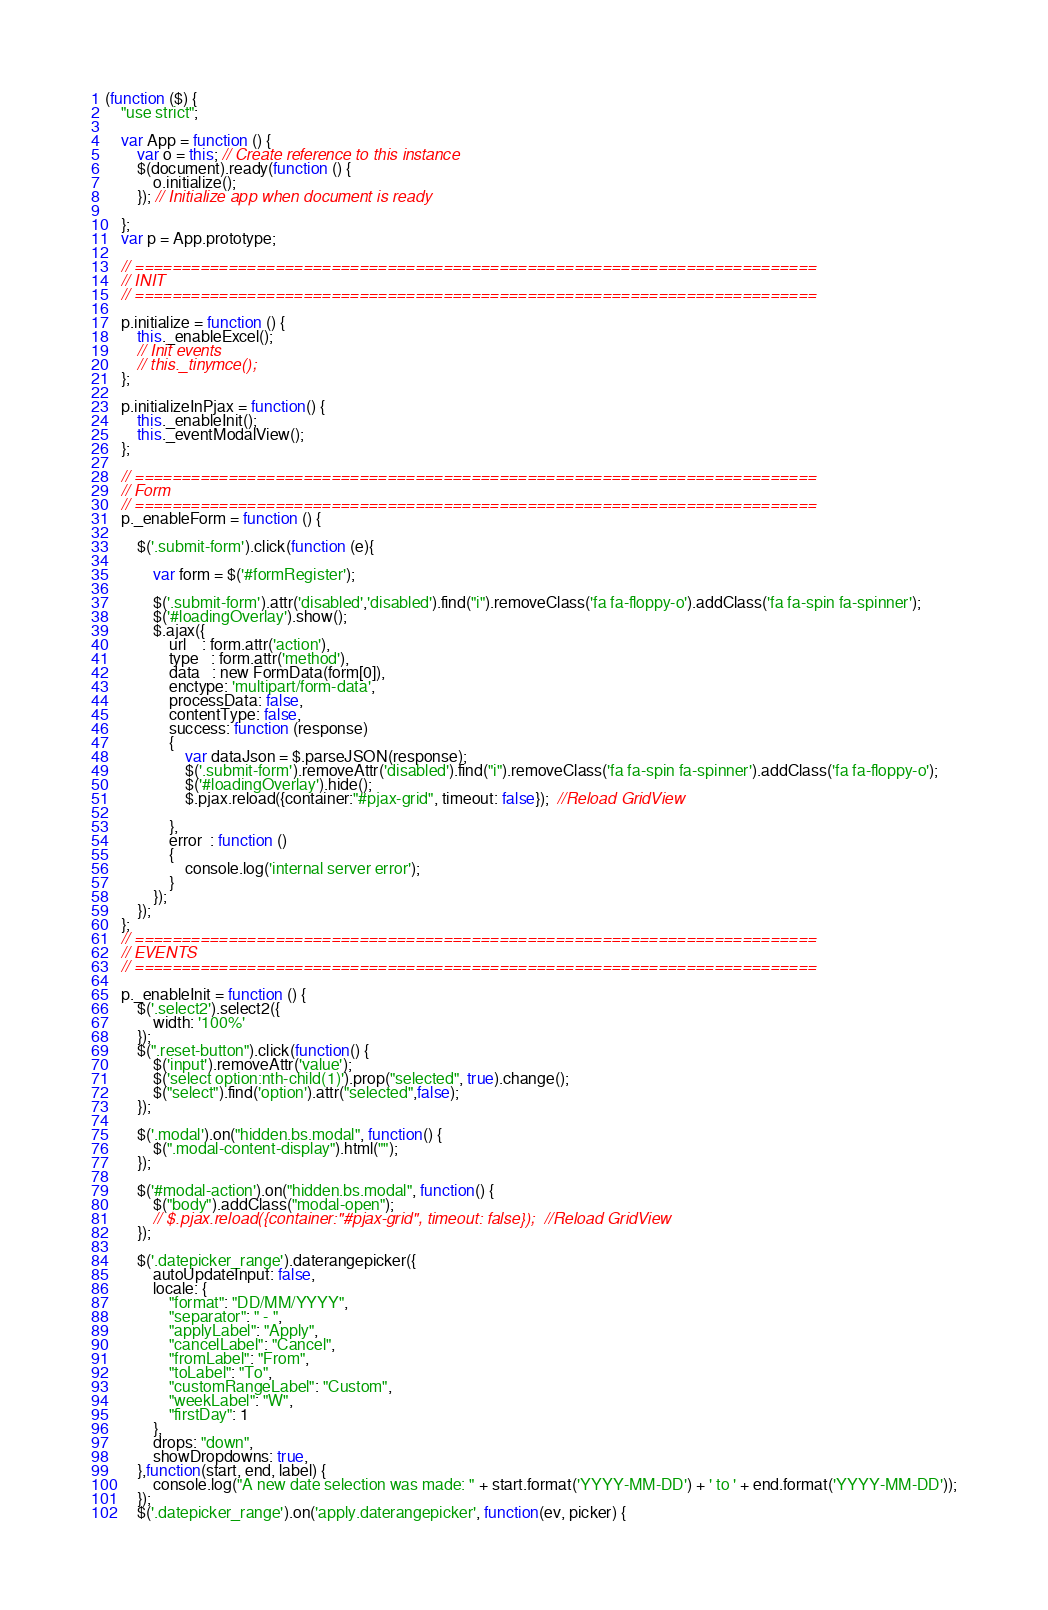Convert code to text. <code><loc_0><loc_0><loc_500><loc_500><_JavaScript_>(function ($) {
	"use strict";

	var App = function () {
		var o = this; // Create reference to this instance
		$(document).ready(function () {
			o.initialize();
		}); // Initialize app when document is ready

	};
	var p = App.prototype;

	// =========================================================================
	// INIT
	// =========================================================================

	p.initialize = function () {
		this._enableExcel();
		// Init events
        // this._tinymce();
    };

    p.initializeInPjax = function() {
    	this._enableInit();
		this._eventModalView();
	};

	// =========================================================================
	// Form
	// =========================================================================
	p._enableForm = function () {

		$('.submit-form').click(function (e){

            var form = $('#formRegister');
          
            $('.submit-form').attr('disabled','disabled').find("i").removeClass('fa fa-floppy-o').addClass('fa fa-spin fa-spinner');
            $('#loadingOverlay').show();
            $.ajax({
                url    : form.attr('action'),
                type   : form.attr('method'),
                data   : new FormData(form[0]),
                enctype: 'multipart/form-data',
                processData: false,
                contentType: false,
                success: function (response) 
                {
                    var dataJson = $.parseJSON(response);
                    $('.submit-form').removeAttr('disabled').find("i").removeClass('fa fa-spin fa-spinner').addClass('fa fa-floppy-o');
                    $('#loadingOverlay').hide();
                    $.pjax.reload({container:"#pjax-grid", timeout: false});  //Reload GridView
                    
                },
                error  : function () 
                {
                    console.log('internal server error');
                }
            });
        });
	};
	// =========================================================================
	// EVENTS
	// =========================================================================

	p._enableInit = function () {
		$('.select2').select2({
            width: '100%'
        });
		$(".reset-button").click(function() {
			$('input').removeAttr('value');
			$('select option:nth-child(1)').prop("selected", true).change();
			$("select").find('option').attr("selected",false);
		});

		$('.modal').on("hidden.bs.modal", function() {
		    $(".modal-content-display").html("");
		}); 

		$('#modal-action').on("hidden.bs.modal", function() {
		    $("body").addClass("modal-open");
		    // $.pjax.reload({container:"#pjax-grid", timeout: false});  //Reload GridView
		}); 

		$('.datepicker_range').daterangepicker({
		    autoUpdateInput: false,
		    locale: {
		        "format": "DD/MM/YYYY",
		        "separator": " - ",
		        "applyLabel": "Apply",
		        "cancelLabel": "Cancel",
		        "fromLabel": "From",
		        "toLabel": "To",
		        "customRangeLabel": "Custom",
		        "weekLabel": "W",
		        "firstDay": 1
		    },
		    drops: "down",
		    showDropdowns: true,
		},function(start, end, label) {
		    console.log("A new date selection was made: " + start.format('YYYY-MM-DD') + ' to ' + end.format('YYYY-MM-DD'));
		});
	    $('.datepicker_range').on('apply.daterangepicker', function(ev, picker) {</code> 